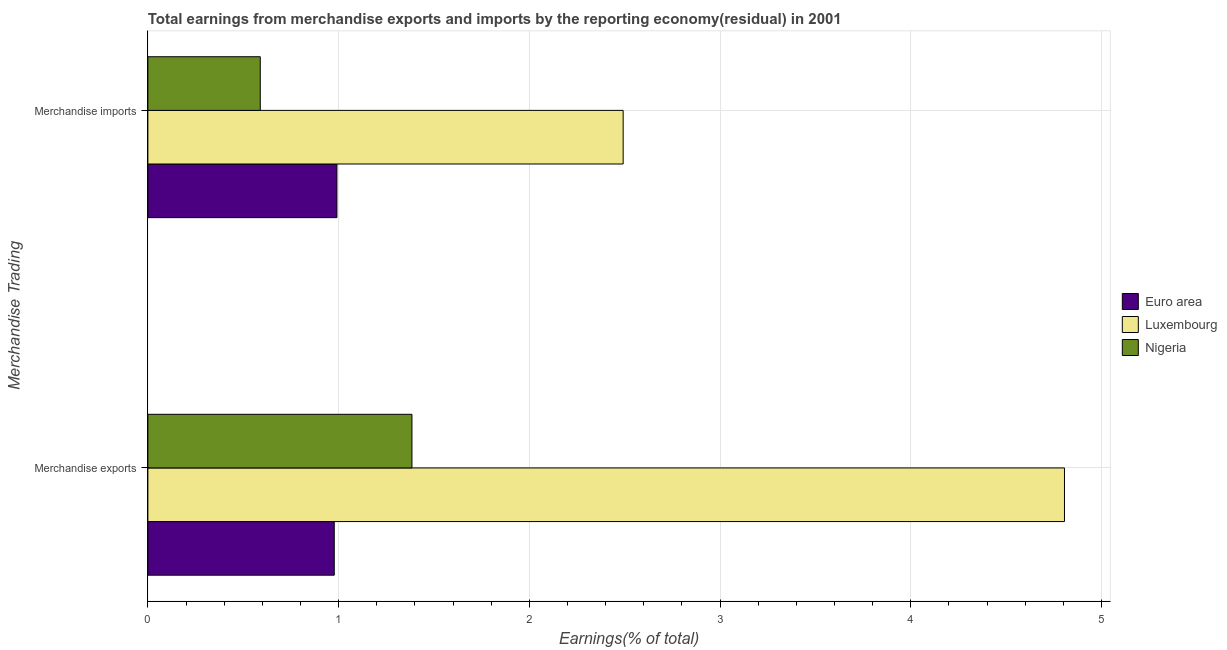What is the label of the 2nd group of bars from the top?
Provide a succinct answer. Merchandise exports. What is the earnings from merchandise exports in Luxembourg?
Your answer should be compact. 4.81. Across all countries, what is the maximum earnings from merchandise exports?
Provide a short and direct response. 4.81. Across all countries, what is the minimum earnings from merchandise imports?
Your answer should be very brief. 0.59. In which country was the earnings from merchandise imports maximum?
Provide a succinct answer. Luxembourg. In which country was the earnings from merchandise imports minimum?
Ensure brevity in your answer.  Nigeria. What is the total earnings from merchandise exports in the graph?
Keep it short and to the point. 7.17. What is the difference between the earnings from merchandise exports in Euro area and that in Nigeria?
Provide a succinct answer. -0.41. What is the difference between the earnings from merchandise imports in Luxembourg and the earnings from merchandise exports in Euro area?
Your answer should be very brief. 1.51. What is the average earnings from merchandise exports per country?
Offer a terse response. 2.39. What is the difference between the earnings from merchandise exports and earnings from merchandise imports in Nigeria?
Provide a short and direct response. 0.8. What is the ratio of the earnings from merchandise imports in Nigeria to that in Euro area?
Offer a very short reply. 0.59. Is the earnings from merchandise imports in Nigeria less than that in Luxembourg?
Your answer should be compact. Yes. What does the 2nd bar from the top in Merchandise exports represents?
Provide a short and direct response. Luxembourg. Are all the bars in the graph horizontal?
Your response must be concise. Yes. How many countries are there in the graph?
Your answer should be compact. 3. What is the difference between two consecutive major ticks on the X-axis?
Offer a very short reply. 1. Are the values on the major ticks of X-axis written in scientific E-notation?
Your answer should be very brief. No. Does the graph contain any zero values?
Provide a short and direct response. No. Does the graph contain grids?
Keep it short and to the point. Yes. How many legend labels are there?
Provide a succinct answer. 3. How are the legend labels stacked?
Your answer should be very brief. Vertical. What is the title of the graph?
Give a very brief answer. Total earnings from merchandise exports and imports by the reporting economy(residual) in 2001. What is the label or title of the X-axis?
Offer a terse response. Earnings(% of total). What is the label or title of the Y-axis?
Keep it short and to the point. Merchandise Trading. What is the Earnings(% of total) in Euro area in Merchandise exports?
Your response must be concise. 0.98. What is the Earnings(% of total) in Luxembourg in Merchandise exports?
Your answer should be very brief. 4.81. What is the Earnings(% of total) in Nigeria in Merchandise exports?
Provide a short and direct response. 1.38. What is the Earnings(% of total) of Euro area in Merchandise imports?
Offer a very short reply. 0.99. What is the Earnings(% of total) of Luxembourg in Merchandise imports?
Offer a very short reply. 2.49. What is the Earnings(% of total) in Nigeria in Merchandise imports?
Give a very brief answer. 0.59. Across all Merchandise Trading, what is the maximum Earnings(% of total) in Euro area?
Keep it short and to the point. 0.99. Across all Merchandise Trading, what is the maximum Earnings(% of total) of Luxembourg?
Give a very brief answer. 4.81. Across all Merchandise Trading, what is the maximum Earnings(% of total) of Nigeria?
Give a very brief answer. 1.38. Across all Merchandise Trading, what is the minimum Earnings(% of total) in Euro area?
Your response must be concise. 0.98. Across all Merchandise Trading, what is the minimum Earnings(% of total) of Luxembourg?
Keep it short and to the point. 2.49. Across all Merchandise Trading, what is the minimum Earnings(% of total) in Nigeria?
Provide a short and direct response. 0.59. What is the total Earnings(% of total) of Euro area in the graph?
Provide a short and direct response. 1.97. What is the total Earnings(% of total) of Luxembourg in the graph?
Keep it short and to the point. 7.3. What is the total Earnings(% of total) in Nigeria in the graph?
Keep it short and to the point. 1.97. What is the difference between the Earnings(% of total) in Euro area in Merchandise exports and that in Merchandise imports?
Provide a succinct answer. -0.01. What is the difference between the Earnings(% of total) in Luxembourg in Merchandise exports and that in Merchandise imports?
Provide a short and direct response. 2.31. What is the difference between the Earnings(% of total) of Nigeria in Merchandise exports and that in Merchandise imports?
Give a very brief answer. 0.8. What is the difference between the Earnings(% of total) of Euro area in Merchandise exports and the Earnings(% of total) of Luxembourg in Merchandise imports?
Your answer should be very brief. -1.51. What is the difference between the Earnings(% of total) in Euro area in Merchandise exports and the Earnings(% of total) in Nigeria in Merchandise imports?
Your answer should be compact. 0.39. What is the difference between the Earnings(% of total) in Luxembourg in Merchandise exports and the Earnings(% of total) in Nigeria in Merchandise imports?
Ensure brevity in your answer.  4.22. What is the average Earnings(% of total) in Euro area per Merchandise Trading?
Make the answer very short. 0.98. What is the average Earnings(% of total) in Luxembourg per Merchandise Trading?
Your response must be concise. 3.65. What is the average Earnings(% of total) of Nigeria per Merchandise Trading?
Make the answer very short. 0.99. What is the difference between the Earnings(% of total) of Euro area and Earnings(% of total) of Luxembourg in Merchandise exports?
Keep it short and to the point. -3.83. What is the difference between the Earnings(% of total) in Euro area and Earnings(% of total) in Nigeria in Merchandise exports?
Provide a short and direct response. -0.41. What is the difference between the Earnings(% of total) of Luxembourg and Earnings(% of total) of Nigeria in Merchandise exports?
Keep it short and to the point. 3.42. What is the difference between the Earnings(% of total) in Euro area and Earnings(% of total) in Luxembourg in Merchandise imports?
Offer a terse response. -1.5. What is the difference between the Earnings(% of total) of Euro area and Earnings(% of total) of Nigeria in Merchandise imports?
Your answer should be very brief. 0.4. What is the difference between the Earnings(% of total) in Luxembourg and Earnings(% of total) in Nigeria in Merchandise imports?
Ensure brevity in your answer.  1.9. What is the ratio of the Earnings(% of total) of Euro area in Merchandise exports to that in Merchandise imports?
Keep it short and to the point. 0.99. What is the ratio of the Earnings(% of total) of Luxembourg in Merchandise exports to that in Merchandise imports?
Give a very brief answer. 1.93. What is the ratio of the Earnings(% of total) in Nigeria in Merchandise exports to that in Merchandise imports?
Your answer should be very brief. 2.35. What is the difference between the highest and the second highest Earnings(% of total) of Euro area?
Give a very brief answer. 0.01. What is the difference between the highest and the second highest Earnings(% of total) of Luxembourg?
Give a very brief answer. 2.31. What is the difference between the highest and the second highest Earnings(% of total) of Nigeria?
Offer a very short reply. 0.8. What is the difference between the highest and the lowest Earnings(% of total) of Euro area?
Your response must be concise. 0.01. What is the difference between the highest and the lowest Earnings(% of total) in Luxembourg?
Provide a succinct answer. 2.31. What is the difference between the highest and the lowest Earnings(% of total) of Nigeria?
Ensure brevity in your answer.  0.8. 